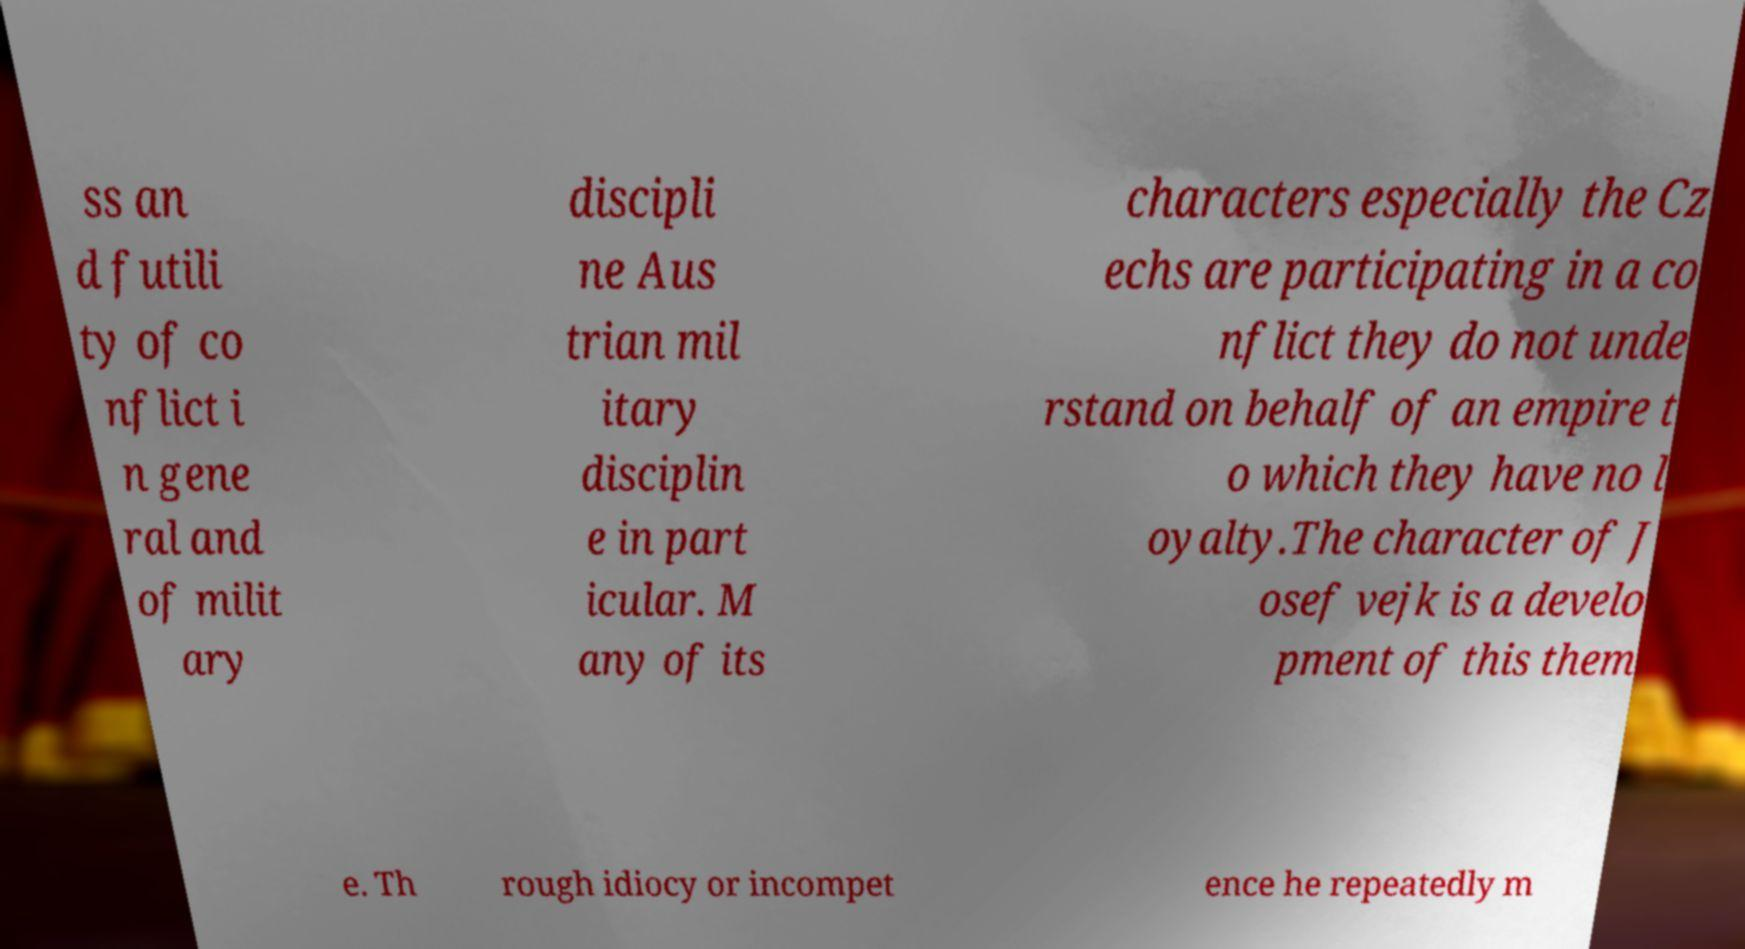Could you assist in decoding the text presented in this image and type it out clearly? ss an d futili ty of co nflict i n gene ral and of milit ary discipli ne Aus trian mil itary disciplin e in part icular. M any of its characters especially the Cz echs are participating in a co nflict they do not unde rstand on behalf of an empire t o which they have no l oyalty.The character of J osef vejk is a develo pment of this them e. Th rough idiocy or incompet ence he repeatedly m 